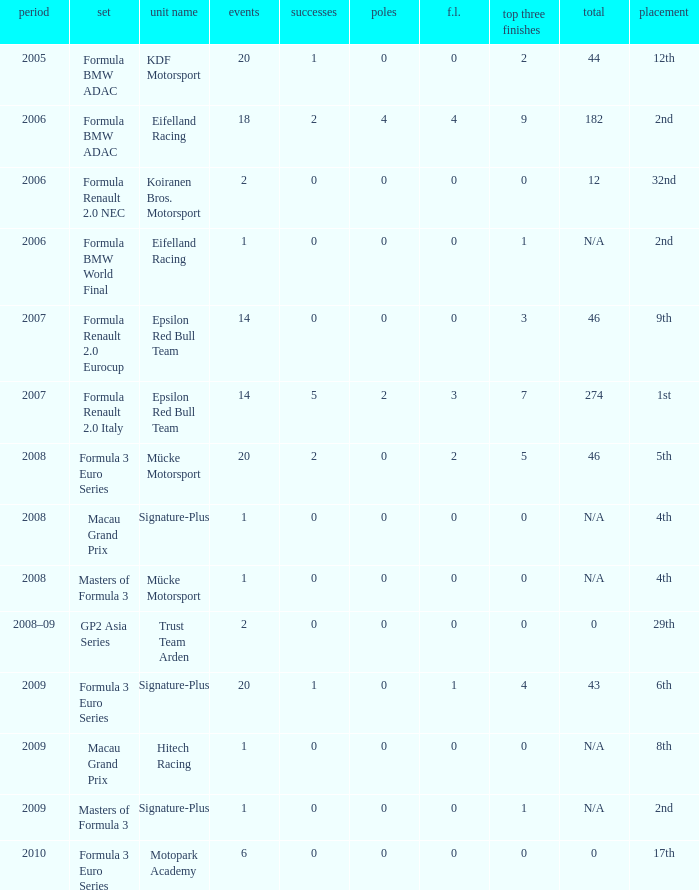What is the average number of podiums in the 32nd position with less than 0 wins? None. 